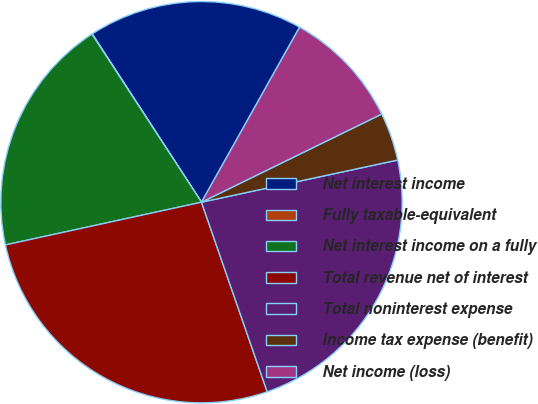Convert chart to OTSL. <chart><loc_0><loc_0><loc_500><loc_500><pie_chart><fcel>Net interest income<fcel>Fully taxable-equivalent<fcel>Net interest income on a fully<fcel>Total revenue net of interest<fcel>Total noninterest expense<fcel>Income tax expense (benefit)<fcel>Net income (loss)<nl><fcel>17.3%<fcel>0.03%<fcel>19.22%<fcel>26.9%<fcel>23.06%<fcel>3.87%<fcel>9.63%<nl></chart> 